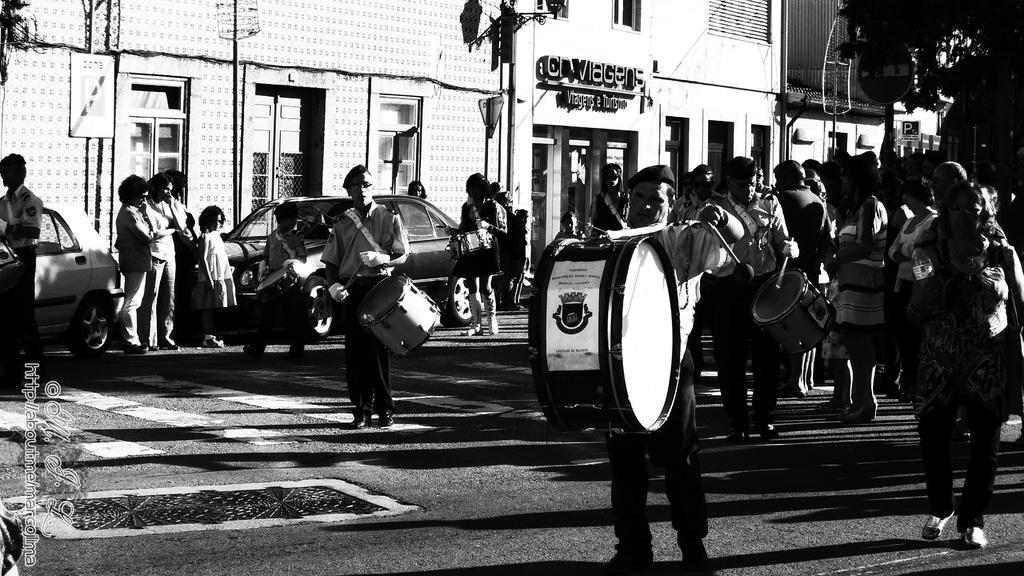Can you describe this image briefly? Group of people standing we can see few persons are holding musical instruments. We can see vehicles on the road. On the background we can see building,tree,board,pole. 